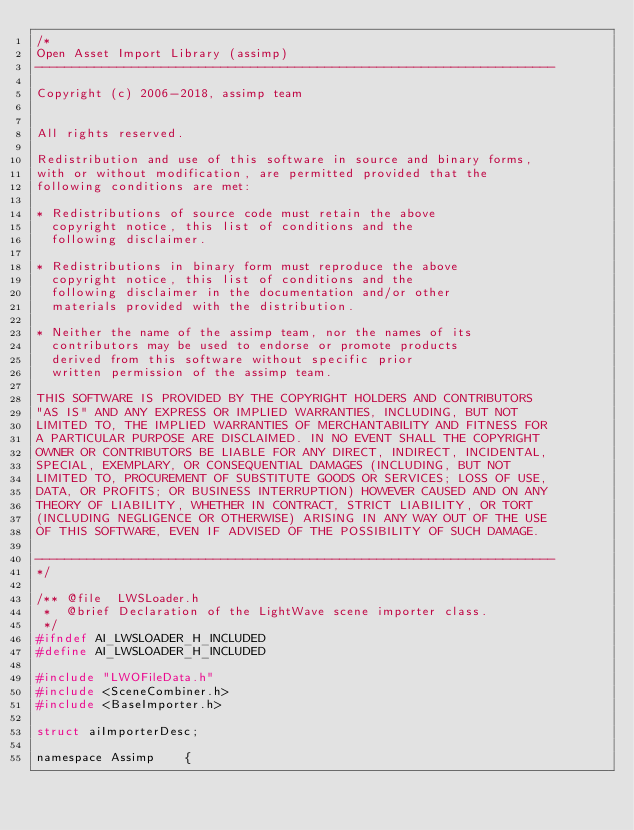Convert code to text. <code><loc_0><loc_0><loc_500><loc_500><_C_>/*
Open Asset Import Library (assimp)
----------------------------------------------------------------------

Copyright (c) 2006-2018, assimp team


All rights reserved.

Redistribution and use of this software in source and binary forms,
with or without modification, are permitted provided that the
following conditions are met:

* Redistributions of source code must retain the above
  copyright notice, this list of conditions and the
  following disclaimer.

* Redistributions in binary form must reproduce the above
  copyright notice, this list of conditions and the
  following disclaimer in the documentation and/or other
  materials provided with the distribution.

* Neither the name of the assimp team, nor the names of its
  contributors may be used to endorse or promote products
  derived from this software without specific prior
  written permission of the assimp team.

THIS SOFTWARE IS PROVIDED BY THE COPYRIGHT HOLDERS AND CONTRIBUTORS
"AS IS" AND ANY EXPRESS OR IMPLIED WARRANTIES, INCLUDING, BUT NOT
LIMITED TO, THE IMPLIED WARRANTIES OF MERCHANTABILITY AND FITNESS FOR
A PARTICULAR PURPOSE ARE DISCLAIMED. IN NO EVENT SHALL THE COPYRIGHT
OWNER OR CONTRIBUTORS BE LIABLE FOR ANY DIRECT, INDIRECT, INCIDENTAL,
SPECIAL, EXEMPLARY, OR CONSEQUENTIAL DAMAGES (INCLUDING, BUT NOT
LIMITED TO, PROCUREMENT OF SUBSTITUTE GOODS OR SERVICES; LOSS OF USE,
DATA, OR PROFITS; OR BUSINESS INTERRUPTION) HOWEVER CAUSED AND ON ANY
THEORY OF LIABILITY, WHETHER IN CONTRACT, STRICT LIABILITY, OR TORT
(INCLUDING NEGLIGENCE OR OTHERWISE) ARISING IN ANY WAY OUT OF THE USE
OF THIS SOFTWARE, EVEN IF ADVISED OF THE POSSIBILITY OF SUCH DAMAGE.

----------------------------------------------------------------------
*/

/** @file  LWSLoader.h
 *  @brief Declaration of the LightWave scene importer class.
 */
#ifndef AI_LWSLOADER_H_INCLUDED
#define AI_LWSLOADER_H_INCLUDED

#include "LWOFileData.h"
#include <SceneCombiner.h>
#include <BaseImporter.h>

struct aiImporterDesc;

namespace Assimp    {</code> 